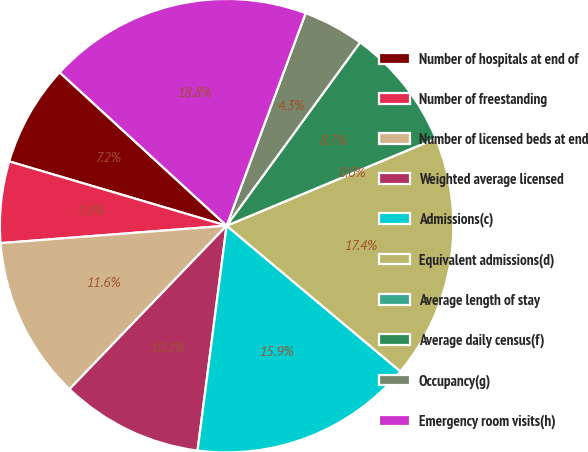Convert chart. <chart><loc_0><loc_0><loc_500><loc_500><pie_chart><fcel>Number of hospitals at end of<fcel>Number of freestanding<fcel>Number of licensed beds at end<fcel>Weighted average licensed<fcel>Admissions(c)<fcel>Equivalent admissions(d)<fcel>Average length of stay<fcel>Average daily census(f)<fcel>Occupancy(g)<fcel>Emergency room visits(h)<nl><fcel>7.25%<fcel>5.8%<fcel>11.59%<fcel>10.14%<fcel>15.94%<fcel>17.39%<fcel>0.0%<fcel>8.7%<fcel>4.35%<fcel>18.84%<nl></chart> 